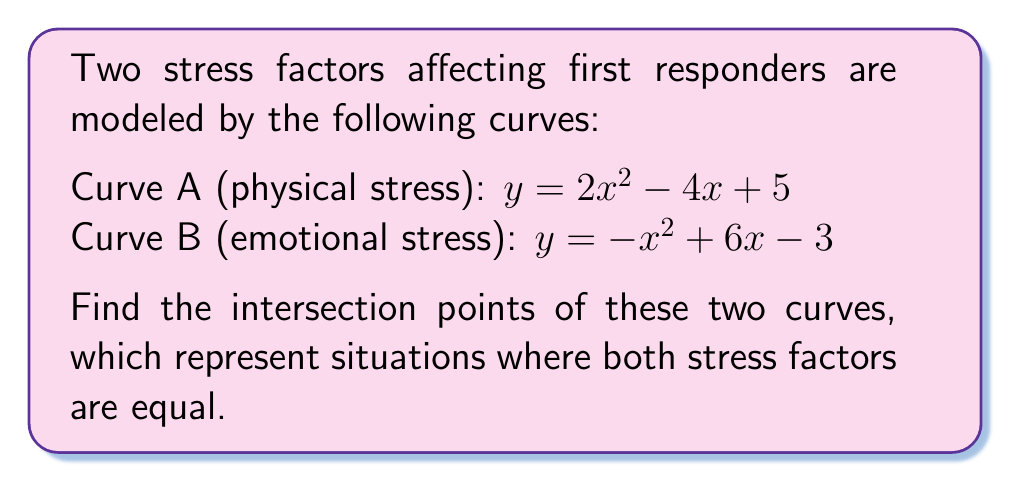Give your solution to this math problem. To find the intersection points, we need to solve the equation where both curves are equal:

1) Set the equations equal to each other:
   $2x^2 - 4x + 5 = -x^2 + 6x - 3$

2) Rearrange all terms to one side:
   $3x^2 - 10x + 8 = 0$

3) This is a quadratic equation. We can solve it using the quadratic formula:
   $x = \frac{-b \pm \sqrt{b^2 - 4ac}}{2a}$

   Where $a = 3$, $b = -10$, and $c = 8$

4) Substitute these values:
   $x = \frac{10 \pm \sqrt{(-10)^2 - 4(3)(8)}}{2(3)}$

5) Simplify:
   $x = \frac{10 \pm \sqrt{100 - 96}}{6} = \frac{10 \pm \sqrt{4}}{6} = \frac{10 \pm 2}{6}$

6) This gives us two solutions:
   $x_1 = \frac{10 + 2}{6} = 2$ and $x_2 = \frac{10 - 2}{6} = \frac{4}{3}$

7) To find the y-coordinates, substitute these x-values into either of the original equations. Let's use Curve A:

   For $x_1 = 2$: $y = 2(2)^2 - 4(2) + 5 = 8 - 8 + 5 = 5$
   For $x_2 = \frac{4}{3}$: $y = 2(\frac{4}{3})^2 - 4(\frac{4}{3}) + 5 = \frac{32}{9} - \frac{16}{3} + 5 = \frac{45}{9} = 5$

Therefore, the intersection points are $(2, 5)$ and $(\frac{4}{3}, 5)$.
Answer: $(2, 5)$ and $(\frac{4}{3}, 5)$ 